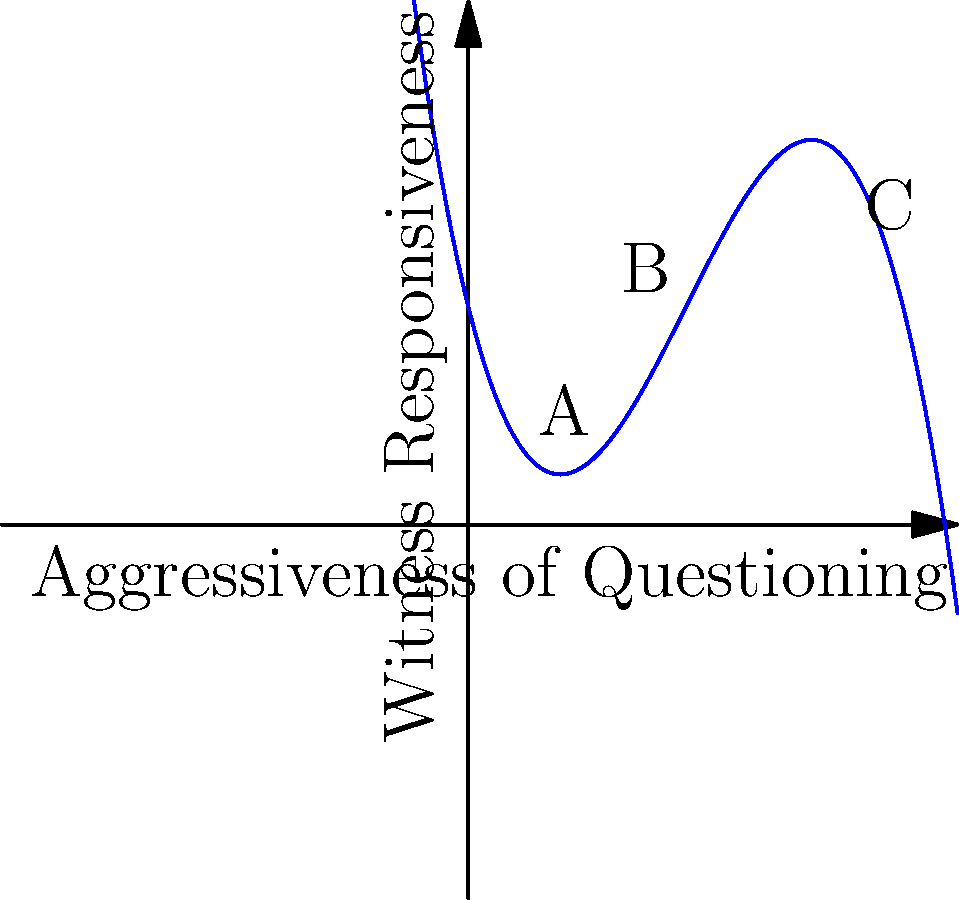The graph represents the relationship between the aggressiveness of questioning techniques and witness responsiveness during cross-examination. Points A, B, and C represent different questioning approaches. Which point likely represents the most effective questioning technique for eliciting responsive answers from a witness, and why? To determine the most effective questioning technique, we need to analyze the graph:

1. The x-axis represents the aggressiveness of questioning, increasing from left to right.
2. The y-axis represents witness responsiveness, increasing from bottom to top.
3. The curve shows how responsiveness changes with aggressiveness.

Let's examine each point:

A: Low aggressiveness, moderate responsiveness
B: Moderate aggressiveness, highest responsiveness
C: High aggressiveness, low responsiveness

Point B represents the peak of the curve, indicating the highest witness responsiveness. This suggests that:

1. A moderate level of aggressiveness is most effective.
2. Too little aggressiveness (Point A) may not sufficiently engage the witness.
3. Too much aggressiveness (Point C) may cause the witness to become defensive or uncooperative.

In cross-examination, the goal is to elicit clear and informative responses. Point B achieves this balance, making it the most effective approach.
Answer: Point B, representing moderate aggressiveness, is the most effective technique for eliciting responsive answers. 